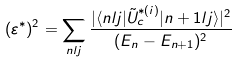<formula> <loc_0><loc_0><loc_500><loc_500>( \varepsilon ^ { * } ) ^ { 2 } = \sum _ { n l j } \frac { | \langle n l j | \tilde { U } ^ { * ( i ) } _ { c } | n + 1 l j \rangle | ^ { 2 } } { ( E _ { n } - E _ { n + 1 } ) ^ { 2 } }</formula> 